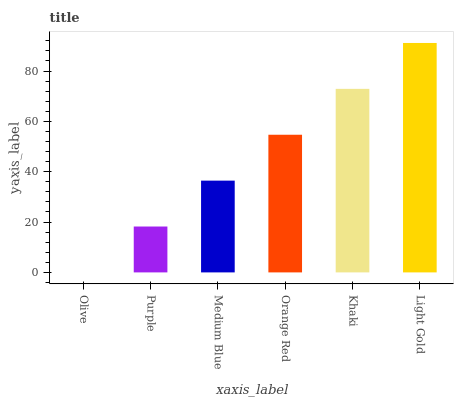Is Purple the minimum?
Answer yes or no. No. Is Purple the maximum?
Answer yes or no. No. Is Purple greater than Olive?
Answer yes or no. Yes. Is Olive less than Purple?
Answer yes or no. Yes. Is Olive greater than Purple?
Answer yes or no. No. Is Purple less than Olive?
Answer yes or no. No. Is Orange Red the high median?
Answer yes or no. Yes. Is Medium Blue the low median?
Answer yes or no. Yes. Is Olive the high median?
Answer yes or no. No. Is Orange Red the low median?
Answer yes or no. No. 